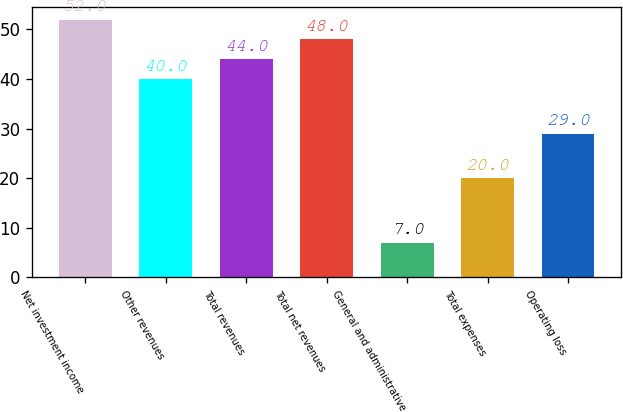Convert chart. <chart><loc_0><loc_0><loc_500><loc_500><bar_chart><fcel>Net investment income<fcel>Other revenues<fcel>Total revenues<fcel>Total net revenues<fcel>General and administrative<fcel>Total expenses<fcel>Operating loss<nl><fcel>52<fcel>40<fcel>44<fcel>48<fcel>7<fcel>20<fcel>29<nl></chart> 